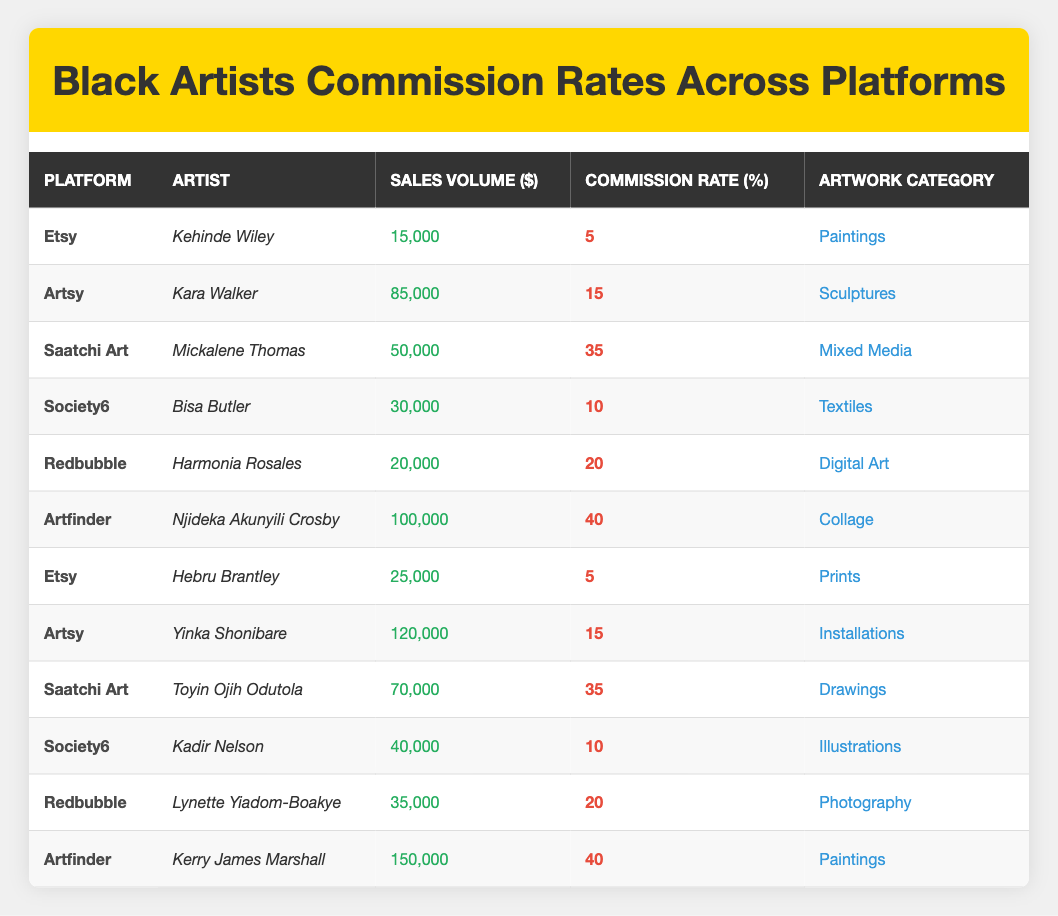What is the commission rate for Kehinde Wiley on Etsy? The table shows that Kehinde Wiley is listed under the Etsy platform with a commission rate of 5%.
Answer: 5% Which artist sold the highest volume of artwork and what was the value? According to the table, Kerry James Marshall sold the highest volume of artwork worth $150,000, which is the maximum sales volume listed.
Answer: 150,000 What is the average commission rate for the artists on Saatchi Art? There are two artists on Saatchi Art: Mickalene Thomas with a commission rate of 35% and Toyin Ojih Odutola also with 35%. Since both have the same rate, the average is (35 + 35) / 2 = 35%.
Answer: 35% Is the commission rate for Harmonia Rosales on Redbubble greater than 15%? The table specifies that Harmonia Rosales has a commission rate of 20% on Redbubble, which is indeed greater than 15%.
Answer: Yes Which platform has the lowest commission rate among the listed artists? Looking through the table, Etsy has the lowest commission rate of 5%, applicable to both Kehinde Wiley and Hebru Brantley.
Answer: Etsy How many artists have a commission rate of 40% and what are their names? There are two artists listed with a commission rate of 40%: Njideka Akunyili Crosby and Kerry James Marshall.
Answer: 2 - Njideka Akunyili Crosby and Kerry James Marshall If we combine the sales volumes of all artists on Society6, what is the total? The artists under Society6 are Bisa Butler with $30,000 and Kadir Nelson with $40,000. Summing these values gives 30,000 + 40,000 = 70,000.
Answer: 70,000 What is the difference in sales volume between the highest and lowest artist on Artsy? On Artsy, Kara Walker has a sales volume of $85,000, and Yinka Shonibare has $120,000. The difference is calculated as 120,000 - 85,000 = 35,000.
Answer: 35,000 Is it true that all artists on Artfinder have the same commission rate? The table shows Njideka Akunyili Crosby and Kerry James Marshall on Artfinder, both with a commission rate of 40%. Thus, it is true that all listed artists on Artfinder have the same rate.
Answer: Yes 